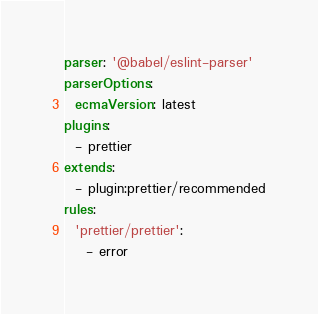Convert code to text. <code><loc_0><loc_0><loc_500><loc_500><_YAML_>parser: '@babel/eslint-parser'
parserOptions:
  ecmaVersion: latest
plugins:
  - prettier
extends:
  - plugin:prettier/recommended
rules:
  'prettier/prettier':
    - error
</code> 